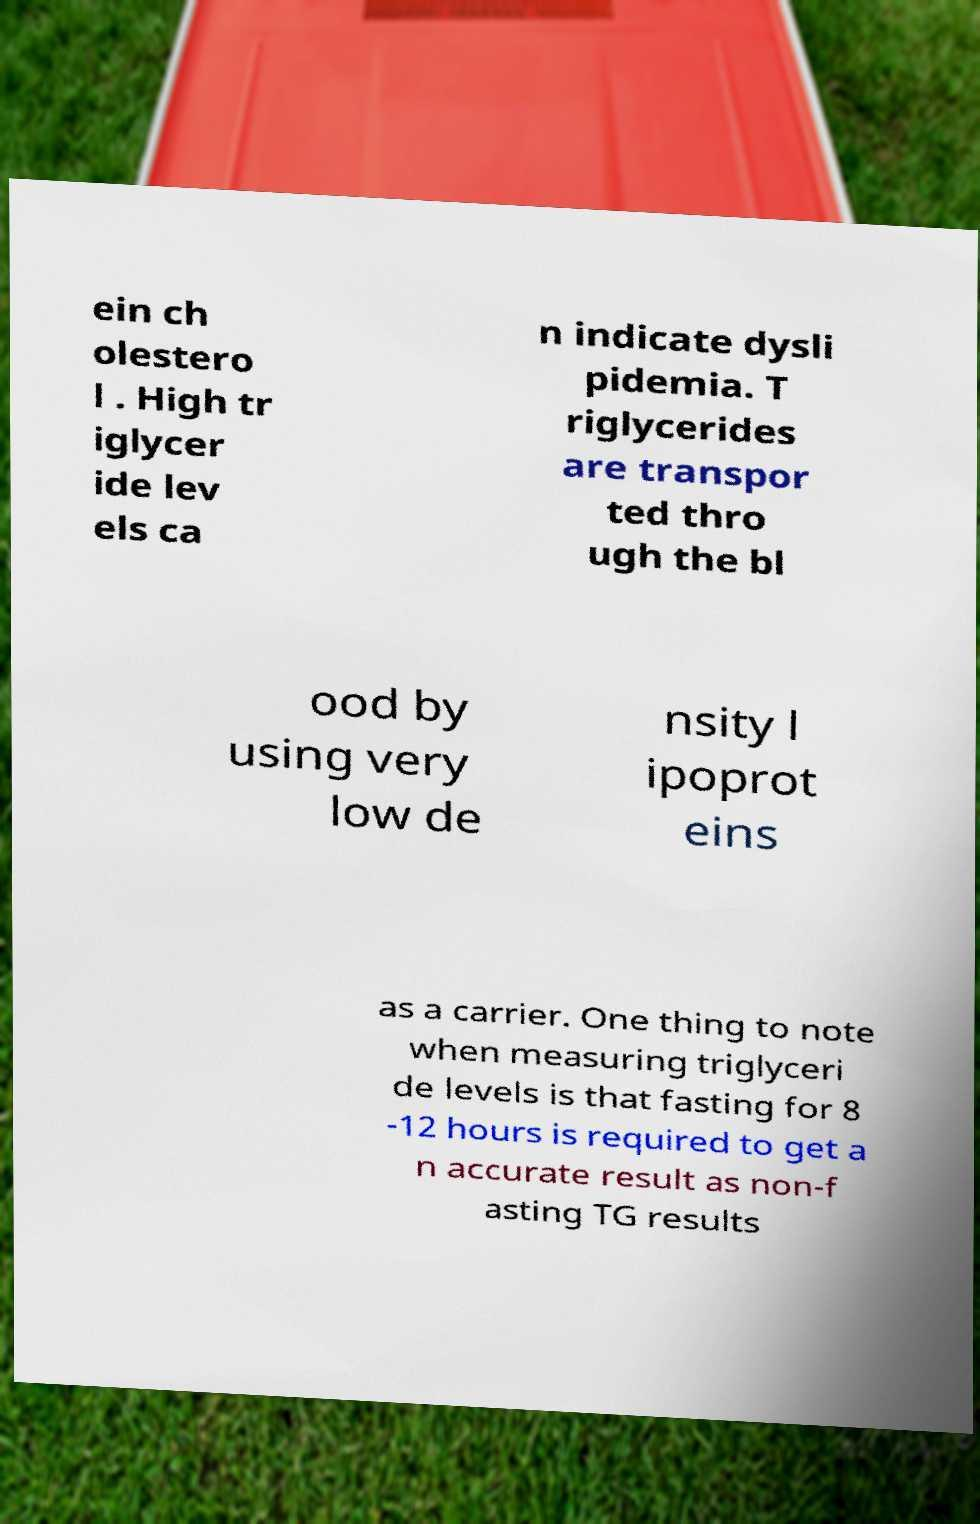Please identify and transcribe the text found in this image. ein ch olestero l . High tr iglycer ide lev els ca n indicate dysli pidemia. T riglycerides are transpor ted thro ugh the bl ood by using very low de nsity l ipoprot eins as a carrier. One thing to note when measuring triglyceri de levels is that fasting for 8 -12 hours is required to get a n accurate result as non-f asting TG results 